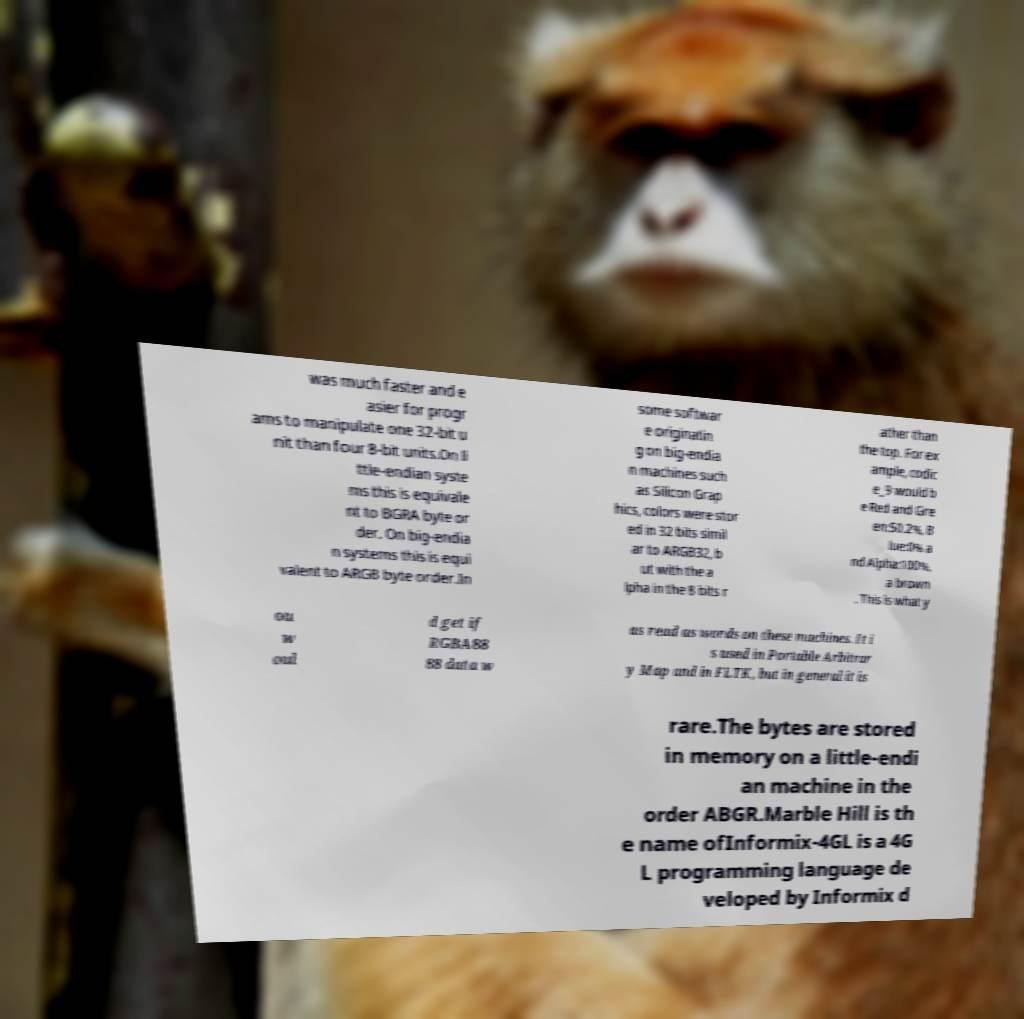Could you extract and type out the text from this image? was much faster and e asier for progr ams to manipulate one 32-bit u nit than four 8-bit units.On li ttle-endian syste ms this is equivale nt to BGRA byte or der. On big-endia n systems this is equi valent to ARGB byte order.In some softwar e originatin g on big-endia n machines such as Silicon Grap hics, colors were stor ed in 32 bits simil ar to ARGB32, b ut with the a lpha in the 8 bits r ather than the top. For ex ample, codic e_9 would b e Red and Gre en:50.2%, B lue:0% a nd Alpha:100%, a brown . This is what y ou w oul d get if RGBA88 88 data w as read as words on these machines. It i s used in Portable Arbitrar y Map and in FLTK, but in general it is rare.The bytes are stored in memory on a little-endi an machine in the order ABGR.Marble Hill is th e name ofInformix-4GL is a 4G L programming language de veloped by Informix d 